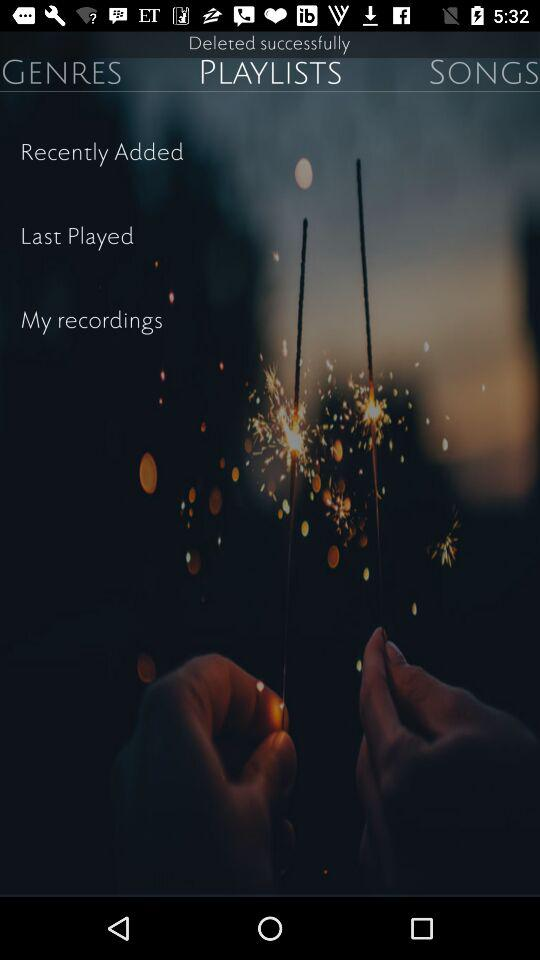How many text elements are in the top half of the screen?
Answer the question using a single word or phrase. 3 